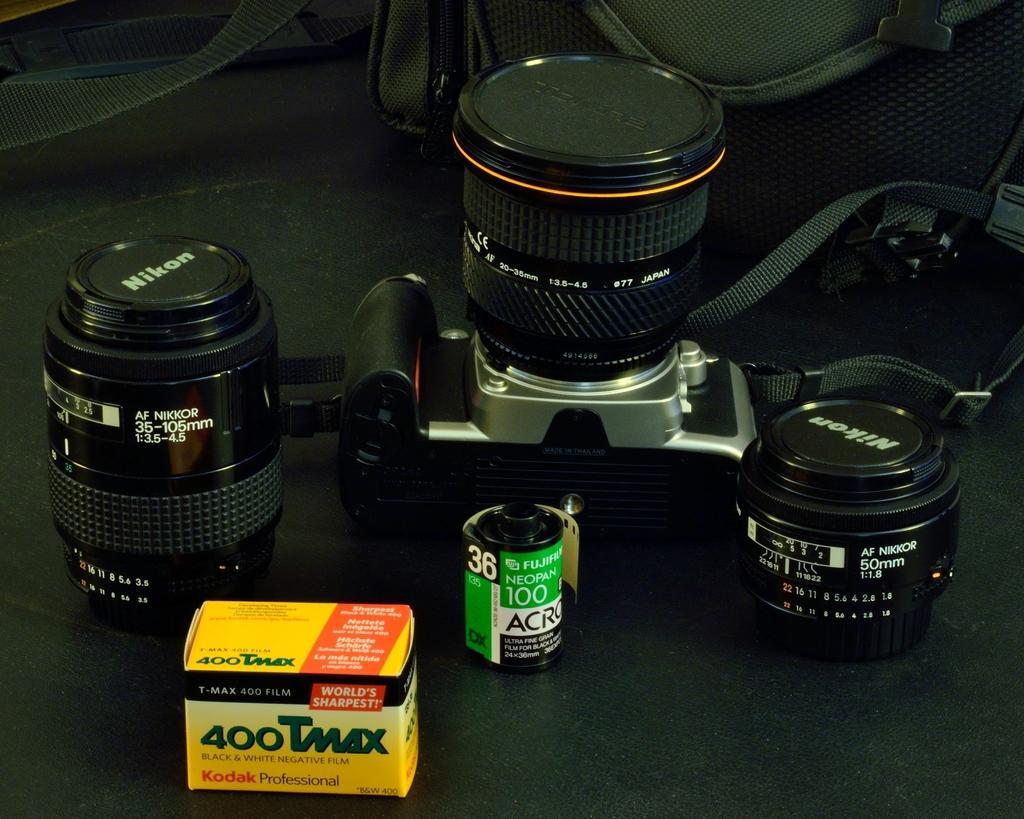In one or two sentences, can you explain what this image depicts? In this image, we can see the camera, film roll, lenses and box are on the black surface. At the top of the image, we can see the bag on the surface. 